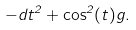<formula> <loc_0><loc_0><loc_500><loc_500>- d t ^ { 2 } + \cos ^ { 2 } ( t ) g .</formula> 